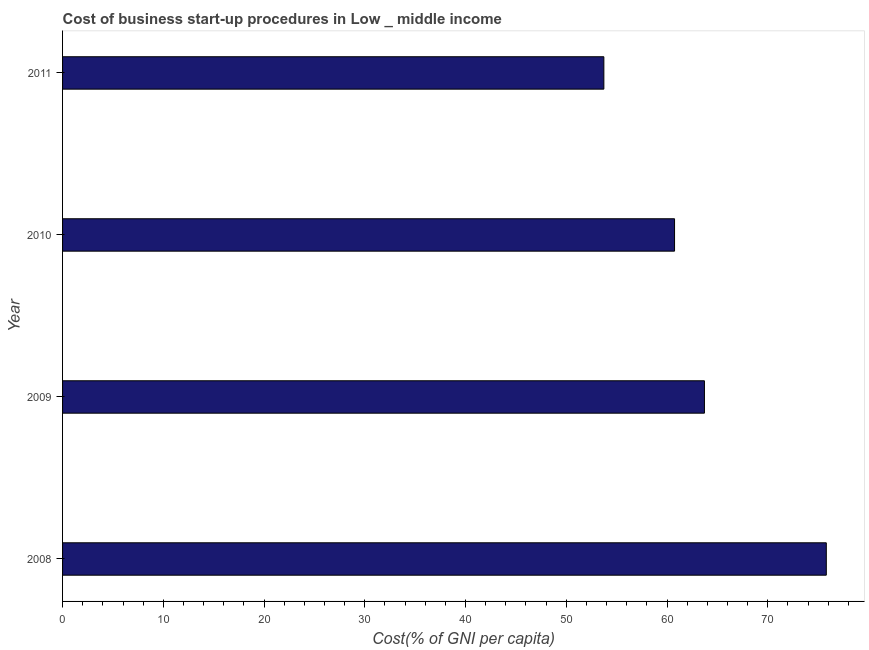Does the graph contain any zero values?
Give a very brief answer. No. What is the title of the graph?
Make the answer very short. Cost of business start-up procedures in Low _ middle income. What is the label or title of the X-axis?
Keep it short and to the point. Cost(% of GNI per capita). What is the label or title of the Y-axis?
Keep it short and to the point. Year. What is the cost of business startup procedures in 2008?
Ensure brevity in your answer.  75.81. Across all years, what is the maximum cost of business startup procedures?
Keep it short and to the point. 75.81. Across all years, what is the minimum cost of business startup procedures?
Provide a short and direct response. 53.73. In which year was the cost of business startup procedures maximum?
Your response must be concise. 2008. What is the sum of the cost of business startup procedures?
Provide a short and direct response. 254.01. What is the difference between the cost of business startup procedures in 2009 and 2010?
Give a very brief answer. 2.97. What is the average cost of business startup procedures per year?
Provide a short and direct response. 63.5. What is the median cost of business startup procedures?
Make the answer very short. 62.23. In how many years, is the cost of business startup procedures greater than 30 %?
Keep it short and to the point. 4. What is the ratio of the cost of business startup procedures in 2008 to that in 2009?
Ensure brevity in your answer.  1.19. Is the cost of business startup procedures in 2009 less than that in 2011?
Your answer should be compact. No. What is the difference between the highest and the second highest cost of business startup procedures?
Make the answer very short. 12.1. What is the difference between the highest and the lowest cost of business startup procedures?
Your response must be concise. 22.08. Are all the bars in the graph horizontal?
Provide a succinct answer. Yes. What is the difference between two consecutive major ticks on the X-axis?
Your answer should be compact. 10. What is the Cost(% of GNI per capita) in 2008?
Your answer should be very brief. 75.81. What is the Cost(% of GNI per capita) in 2009?
Offer a terse response. 63.72. What is the Cost(% of GNI per capita) in 2010?
Offer a very short reply. 60.75. What is the Cost(% of GNI per capita) in 2011?
Ensure brevity in your answer.  53.73. What is the difference between the Cost(% of GNI per capita) in 2008 and 2009?
Your answer should be very brief. 12.1. What is the difference between the Cost(% of GNI per capita) in 2008 and 2010?
Provide a short and direct response. 15.06. What is the difference between the Cost(% of GNI per capita) in 2008 and 2011?
Give a very brief answer. 22.08. What is the difference between the Cost(% of GNI per capita) in 2009 and 2010?
Offer a very short reply. 2.97. What is the difference between the Cost(% of GNI per capita) in 2009 and 2011?
Offer a terse response. 9.98. What is the difference between the Cost(% of GNI per capita) in 2010 and 2011?
Provide a short and direct response. 7.02. What is the ratio of the Cost(% of GNI per capita) in 2008 to that in 2009?
Offer a terse response. 1.19. What is the ratio of the Cost(% of GNI per capita) in 2008 to that in 2010?
Offer a very short reply. 1.25. What is the ratio of the Cost(% of GNI per capita) in 2008 to that in 2011?
Make the answer very short. 1.41. What is the ratio of the Cost(% of GNI per capita) in 2009 to that in 2010?
Offer a terse response. 1.05. What is the ratio of the Cost(% of GNI per capita) in 2009 to that in 2011?
Offer a terse response. 1.19. What is the ratio of the Cost(% of GNI per capita) in 2010 to that in 2011?
Your answer should be compact. 1.13. 